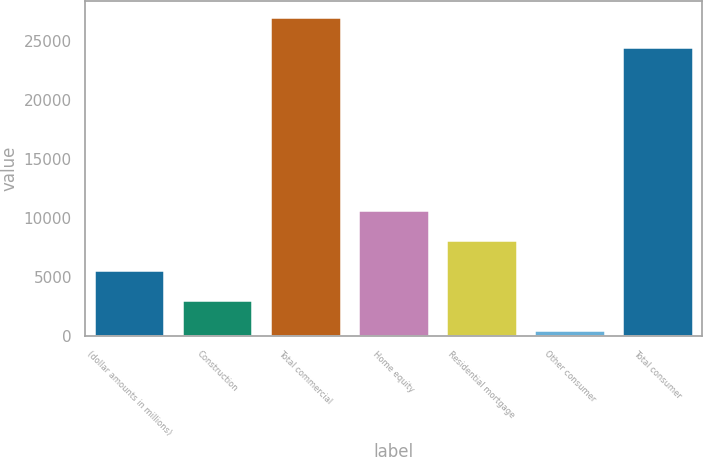Convert chart to OTSL. <chart><loc_0><loc_0><loc_500><loc_500><bar_chart><fcel>(dollar amounts in millions)<fcel>Construction<fcel>Total commercial<fcel>Home equity<fcel>Residential mortgage<fcel>Other consumer<fcel>Total consumer<nl><fcel>5616<fcel>3089.5<fcel>27039.5<fcel>10669<fcel>8142.5<fcel>563<fcel>24513<nl></chart> 